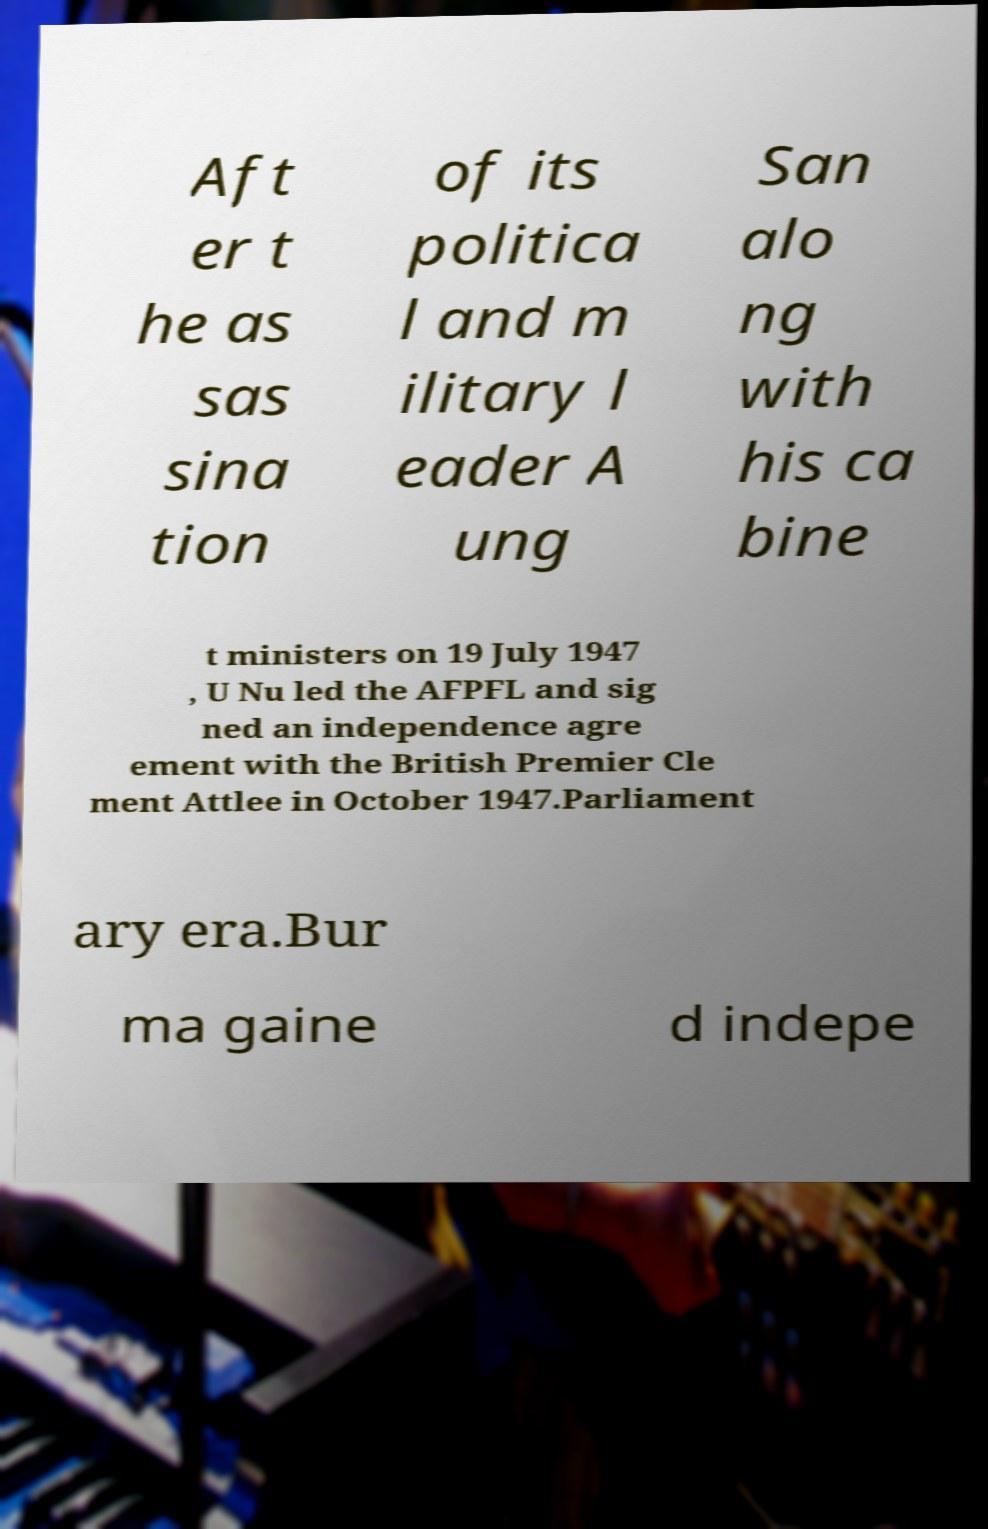Please identify and transcribe the text found in this image. Aft er t he as sas sina tion of its politica l and m ilitary l eader A ung San alo ng with his ca bine t ministers on 19 July 1947 , U Nu led the AFPFL and sig ned an independence agre ement with the British Premier Cle ment Attlee in October 1947.Parliament ary era.Bur ma gaine d indepe 